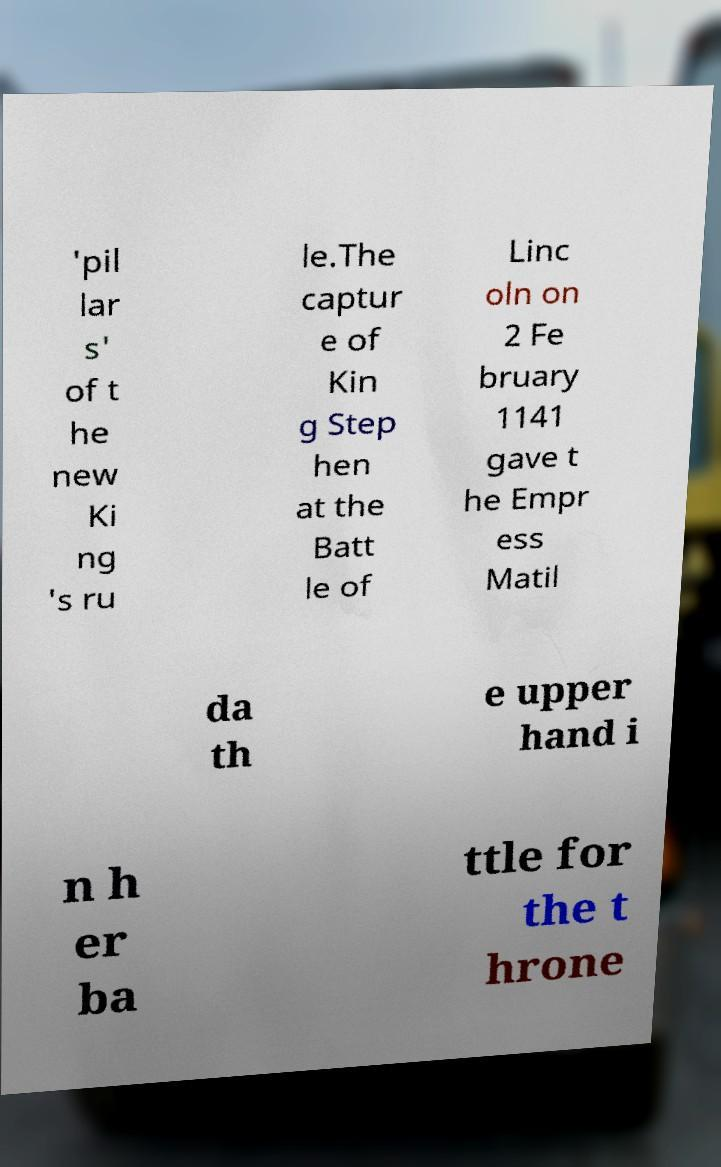Could you extract and type out the text from this image? 'pil lar s' of t he new Ki ng 's ru le.The captur e of Kin g Step hen at the Batt le of Linc oln on 2 Fe bruary 1141 gave t he Empr ess Matil da th e upper hand i n h er ba ttle for the t hrone 